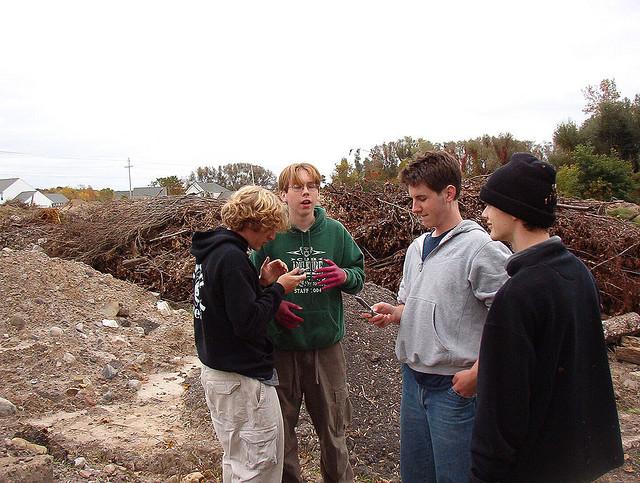How many boys?
Keep it brief. 4. What is behind the neck?
Quick response, please. Hood. Are they wearing dresses?
Keep it brief. No. How many boys are wearing a top with a hood?
Short answer required. 3. What is the number on the woman's back?
Short answer required. 0. What activity is taking place between the two young men?
Answer briefly. Talking. Are the children lost?
Short answer required. No. 